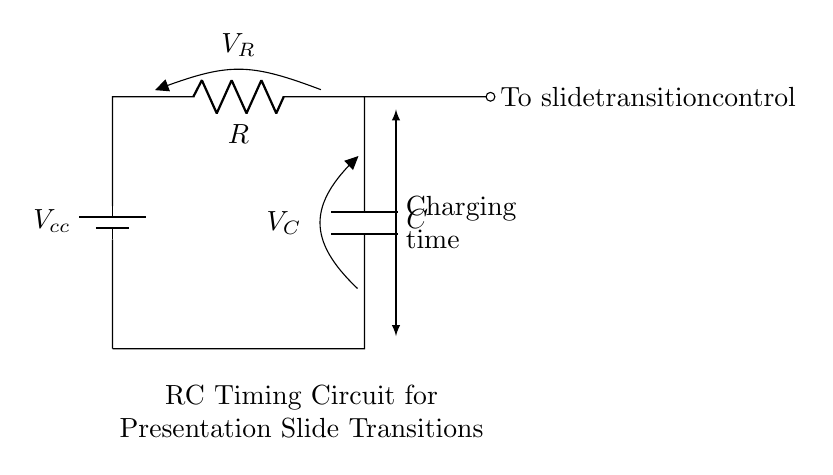What type of circuit is represented? This circuit is a Resistor-Capacitor (RC) timing circuit, characterized by the presence of a resistor and a capacitor connected in series. This setup is typically used for timing applications.
Answer: RC timing circuit What is the role of the resistor in this circuit? The resistor in this circuit limits the current flow and affects the charging time of the capacitor, influencing how quickly the capacitor can charge to the supply voltage.
Answer: Current limiting What does the capacitor store in this circuit? The capacitor stores electric charge, which gradually increases as the capacitor charges through the resistor until it reaches the battery voltage, influencing the timing of slide transitions.
Answer: Electric charge What is the function of the voltage across the capacitor labeled as? The voltage across the capacitor is labeled as \(V_C\), indicating the potential difference across the capacitor which changes as it charges over time.
Answer: \(V_C\) How does increasing resistance affect the charging time? Increasing the resistance slows down the charging process of the capacitor, leading to a longer time constant, which in turn results in slower transitions in presentation slides.
Answer: Slower transitions What happens when the capacitor is fully charged? When the capacitor is fully charged, it reaches the supply voltage \(V_{cc}\), at which point the current stops flowing into the capacitor, and it retains the voltage until it is discharged.
Answer: Current stops flowing 